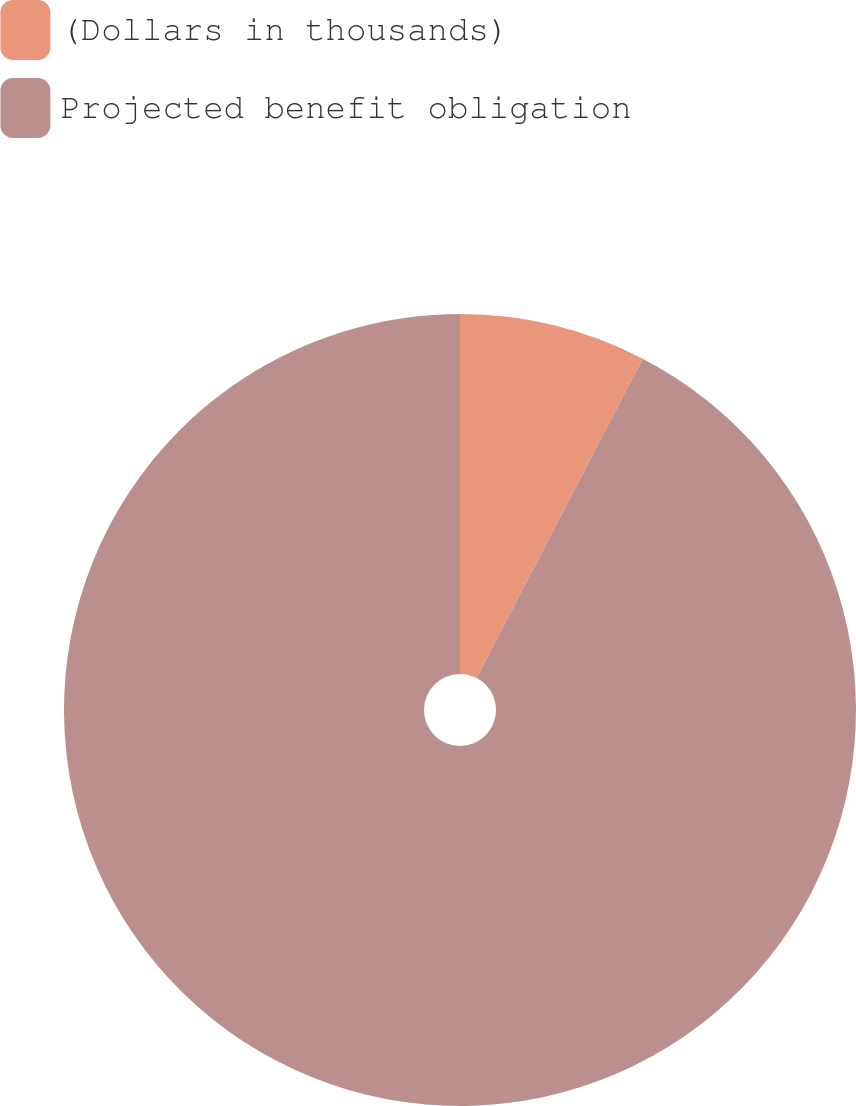Convert chart. <chart><loc_0><loc_0><loc_500><loc_500><pie_chart><fcel>(Dollars in thousands)<fcel>Projected benefit obligation<nl><fcel>7.63%<fcel>92.37%<nl></chart> 